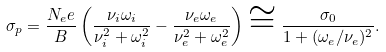Convert formula to latex. <formula><loc_0><loc_0><loc_500><loc_500>\sigma _ { p } = \frac { N _ { e } e } { B } \left ( \frac { \nu _ { i } \omega _ { i } } { \nu _ { i } ^ { 2 } + \omega _ { i } ^ { 2 } } - \frac { \nu _ { e } \omega _ { e } } { \nu _ { e } ^ { 2 } + \omega _ { e } ^ { 2 } } \right ) \cong \frac { \sigma _ { 0 } } { 1 + ( \omega _ { e } / \nu _ { e } ) ^ { 2 } } .</formula> 